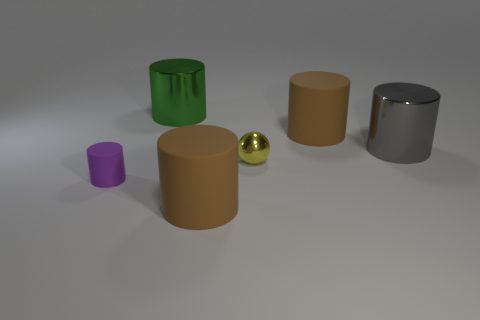Subtract all big green metallic cylinders. How many cylinders are left? 4 Subtract 1 cylinders. How many cylinders are left? 4 Subtract all purple cylinders. How many cylinders are left? 4 Subtract all cyan cylinders. Subtract all yellow blocks. How many cylinders are left? 5 Add 1 large brown objects. How many objects exist? 7 Subtract all cylinders. How many objects are left? 1 Add 6 tiny objects. How many tiny objects are left? 8 Add 2 yellow shiny spheres. How many yellow shiny spheres exist? 3 Subtract 0 green blocks. How many objects are left? 6 Subtract all large cyan spheres. Subtract all small purple cylinders. How many objects are left? 5 